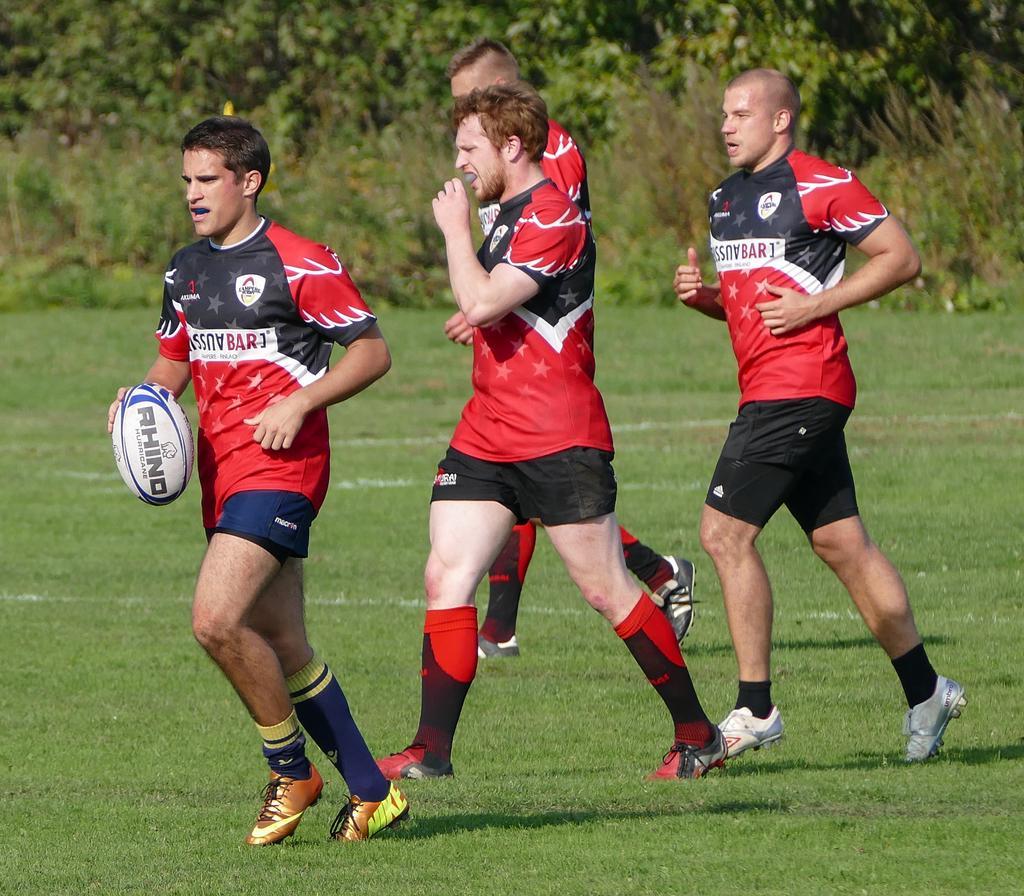Can you describe this image briefly? In this image, we can see people wearing sports dress and are running and one of them is holding a ball. At the bottom, there is ground and in the background, there are trees. 